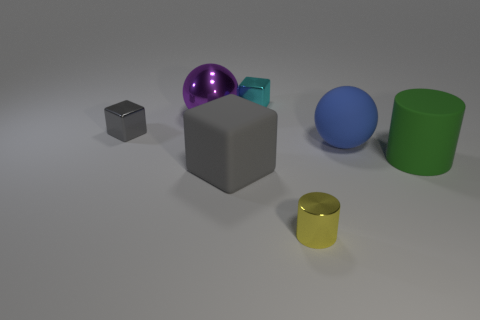What number of other objects are there of the same shape as the blue rubber thing?
Provide a short and direct response. 1. The block that is the same size as the green matte cylinder is what color?
Ensure brevity in your answer.  Gray. What number of objects are big gray rubber things or small purple metallic cubes?
Offer a terse response. 1. Are there any shiny blocks to the right of the purple sphere?
Keep it short and to the point. Yes. Are there any large cubes that have the same material as the big blue thing?
Provide a short and direct response. Yes. How many cylinders are small gray metallic objects or large blue objects?
Provide a short and direct response. 0. Are there more blocks that are in front of the large purple sphere than rubber balls to the left of the big blue matte object?
Your answer should be very brief. Yes. What number of objects have the same color as the big block?
Your response must be concise. 1. There is a green object that is made of the same material as the large blue ball; what size is it?
Your answer should be very brief. Large. How many things are either metallic things that are to the left of the large gray object or small cyan balls?
Provide a short and direct response. 2. 